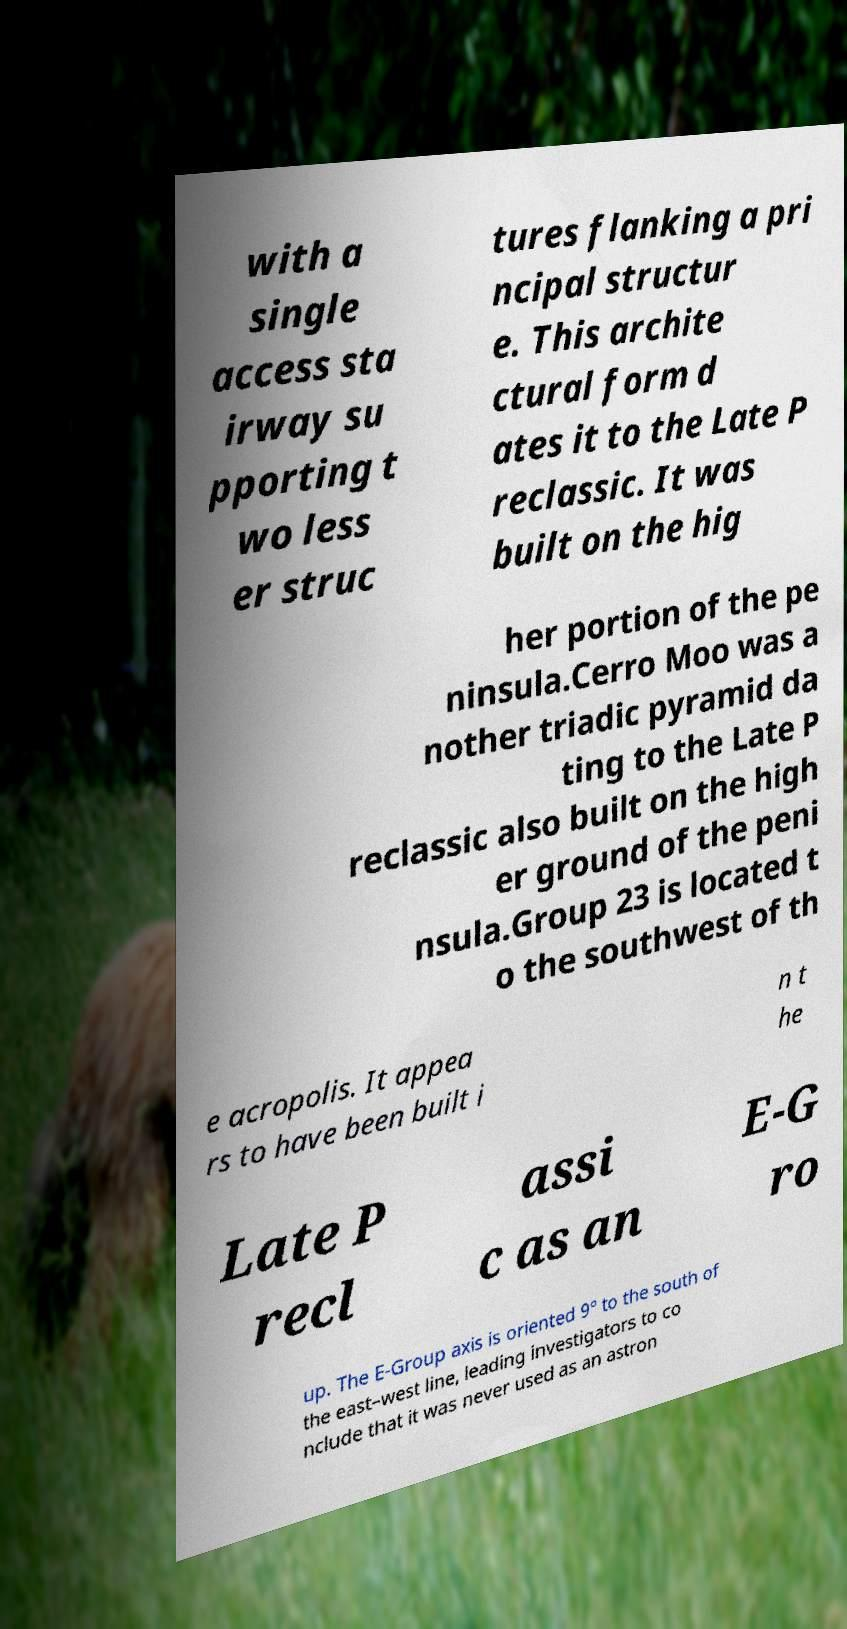I need the written content from this picture converted into text. Can you do that? with a single access sta irway su pporting t wo less er struc tures flanking a pri ncipal structur e. This archite ctural form d ates it to the Late P reclassic. It was built on the hig her portion of the pe ninsula.Cerro Moo was a nother triadic pyramid da ting to the Late P reclassic also built on the high er ground of the peni nsula.Group 23 is located t o the southwest of th e acropolis. It appea rs to have been built i n t he Late P recl assi c as an E-G ro up. The E-Group axis is oriented 9° to the south of the east–west line, leading investigators to co nclude that it was never used as an astron 